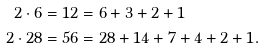<formula> <loc_0><loc_0><loc_500><loc_500>2 \cdot 6 & = 1 2 = 6 + 3 + 2 + 1 \\ 2 \cdot 2 8 & = 5 6 = 2 8 + 1 4 + 7 + 4 + 2 + 1 .</formula> 